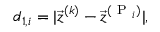<formula> <loc_0><loc_0><loc_500><loc_500>d _ { 1 , i } = | \vec { z } ^ { ( k ) } - \vec { z } ^ { ( P _ { i } ) } | ,</formula> 